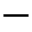<formula> <loc_0><loc_0><loc_500><loc_500>-</formula> 